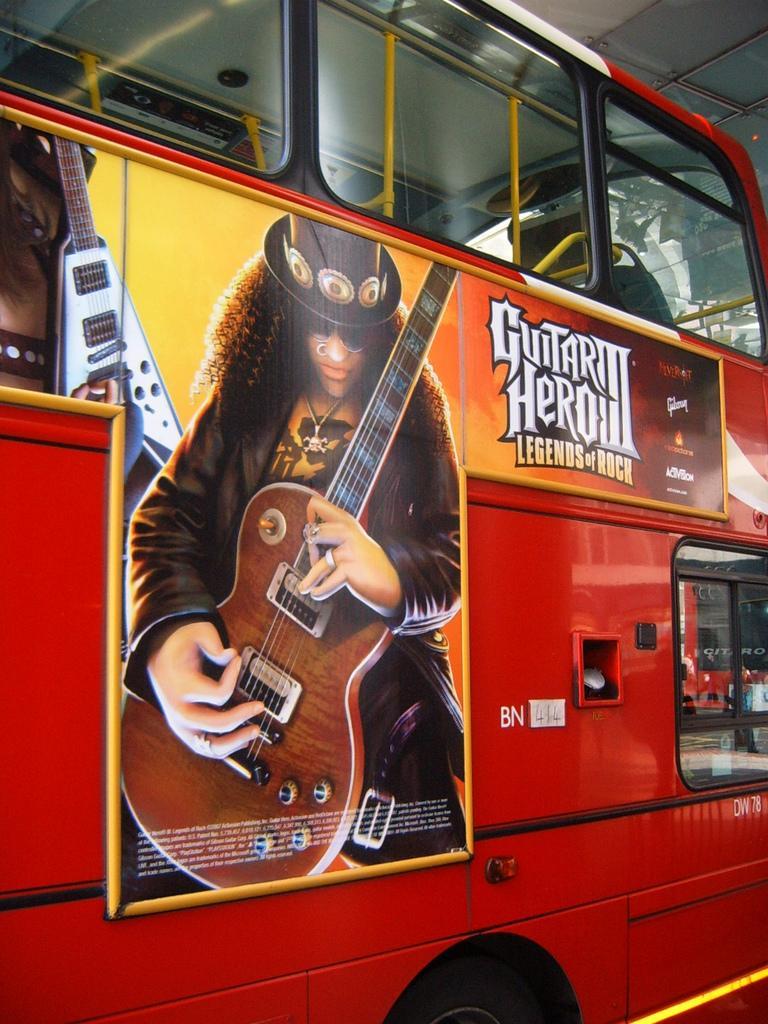How would you summarize this image in a sentence or two? In this picture there is a bus on which a poster was stuck. On this poster there is a man, wearing a hat, holding a guitar in his hands. 